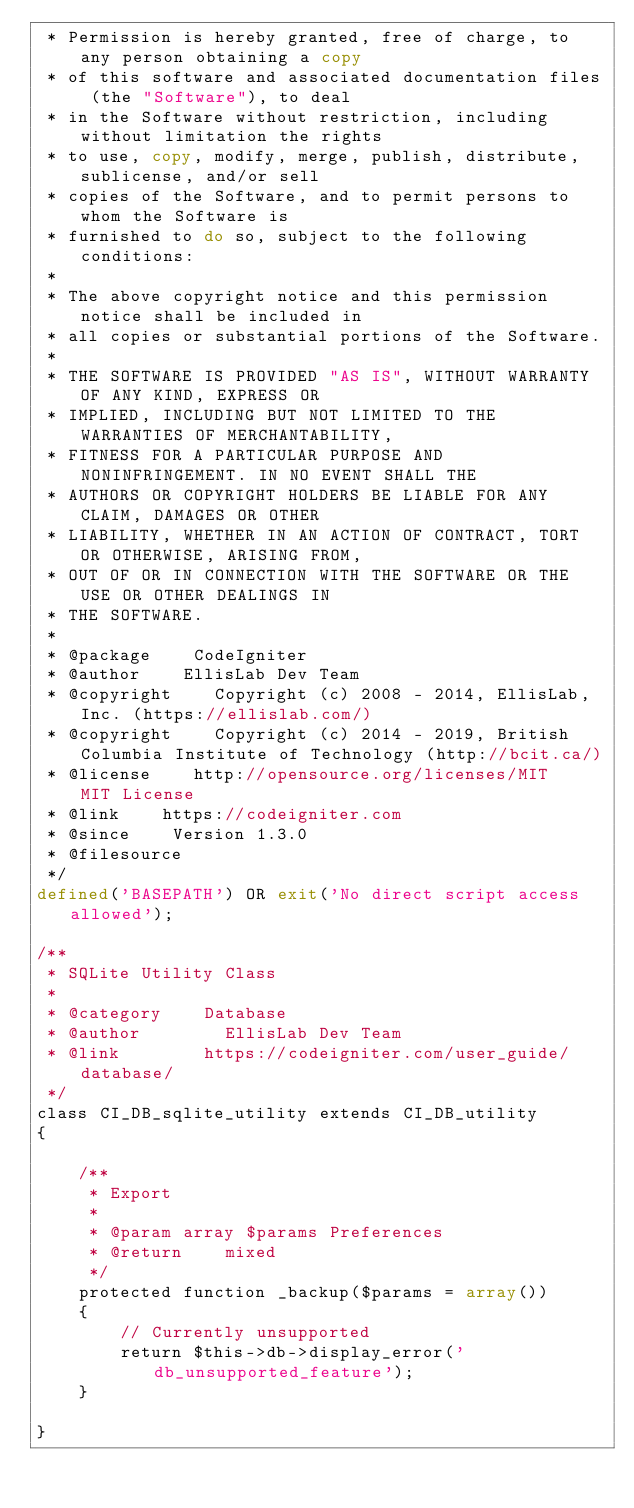Convert code to text. <code><loc_0><loc_0><loc_500><loc_500><_PHP_> * Permission is hereby granted, free of charge, to any person obtaining a copy
 * of this software and associated documentation files (the "Software"), to deal
 * in the Software without restriction, including without limitation the rights
 * to use, copy, modify, merge, publish, distribute, sublicense, and/or sell
 * copies of the Software, and to permit persons to whom the Software is
 * furnished to do so, subject to the following conditions:
 *
 * The above copyright notice and this permission notice shall be included in
 * all copies or substantial portions of the Software.
 *
 * THE SOFTWARE IS PROVIDED "AS IS", WITHOUT WARRANTY OF ANY KIND, EXPRESS OR
 * IMPLIED, INCLUDING BUT NOT LIMITED TO THE WARRANTIES OF MERCHANTABILITY,
 * FITNESS FOR A PARTICULAR PURPOSE AND NONINFRINGEMENT. IN NO EVENT SHALL THE
 * AUTHORS OR COPYRIGHT HOLDERS BE LIABLE FOR ANY CLAIM, DAMAGES OR OTHER
 * LIABILITY, WHETHER IN AN ACTION OF CONTRACT, TORT OR OTHERWISE, ARISING FROM,
 * OUT OF OR IN CONNECTION WITH THE SOFTWARE OR THE USE OR OTHER DEALINGS IN
 * THE SOFTWARE.
 *
 * @package    CodeIgniter
 * @author    EllisLab Dev Team
 * @copyright    Copyright (c) 2008 - 2014, EllisLab, Inc. (https://ellislab.com/)
 * @copyright    Copyright (c) 2014 - 2019, British Columbia Institute of Technology (http://bcit.ca/)
 * @license    http://opensource.org/licenses/MIT	MIT License
 * @link    https://codeigniter.com
 * @since    Version 1.3.0
 * @filesource
 */
defined('BASEPATH') OR exit('No direct script access allowed');

/**
 * SQLite Utility Class
 *
 * @category    Database
 * @author        EllisLab Dev Team
 * @link        https://codeigniter.com/user_guide/database/
 */
class CI_DB_sqlite_utility extends CI_DB_utility
{

    /**
     * Export
     *
     * @param array $params Preferences
     * @return    mixed
     */
    protected function _backup($params = array())
    {
        // Currently unsupported
        return $this->db->display_error('db_unsupported_feature');
    }

}
</code> 